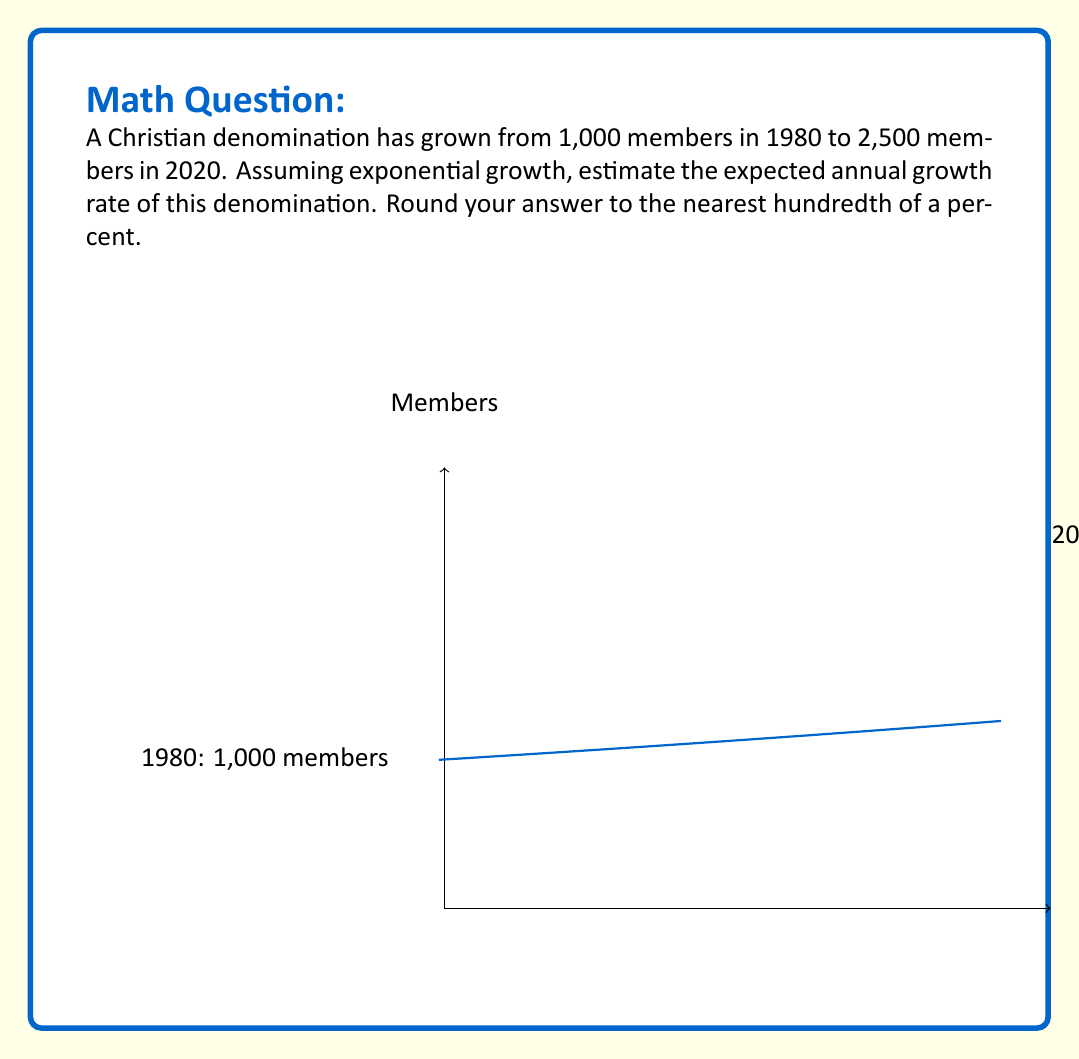Help me with this question. To solve this problem, we'll use the exponential growth formula:

$$A = P(1 + r)^t$$

Where:
$A$ is the final amount (2,500 members)
$P$ is the initial amount (1,000 members)
$r$ is the annual growth rate (what we're solving for)
$t$ is the time period (40 years, from 1980 to 2020)

Step 1: Substitute the known values into the formula:
$$2500 = 1000(1 + r)^{40}$$

Step 2: Divide both sides by 1000:
$$2.5 = (1 + r)^{40}$$

Step 3: Take the 40th root of both sides:
$$\sqrt[40]{2.5} = 1 + r$$

Step 4: Subtract 1 from both sides:
$$\sqrt[40]{2.5} - 1 = r$$

Step 5: Calculate the value:
$$r = 1.0228 - 1 = 0.0228$$

Step 6: Convert to a percentage and round to the nearest hundredth:
$$r = 2.28\%$$

Therefore, the estimated annual growth rate is 2.28%.
Answer: 2.28% 